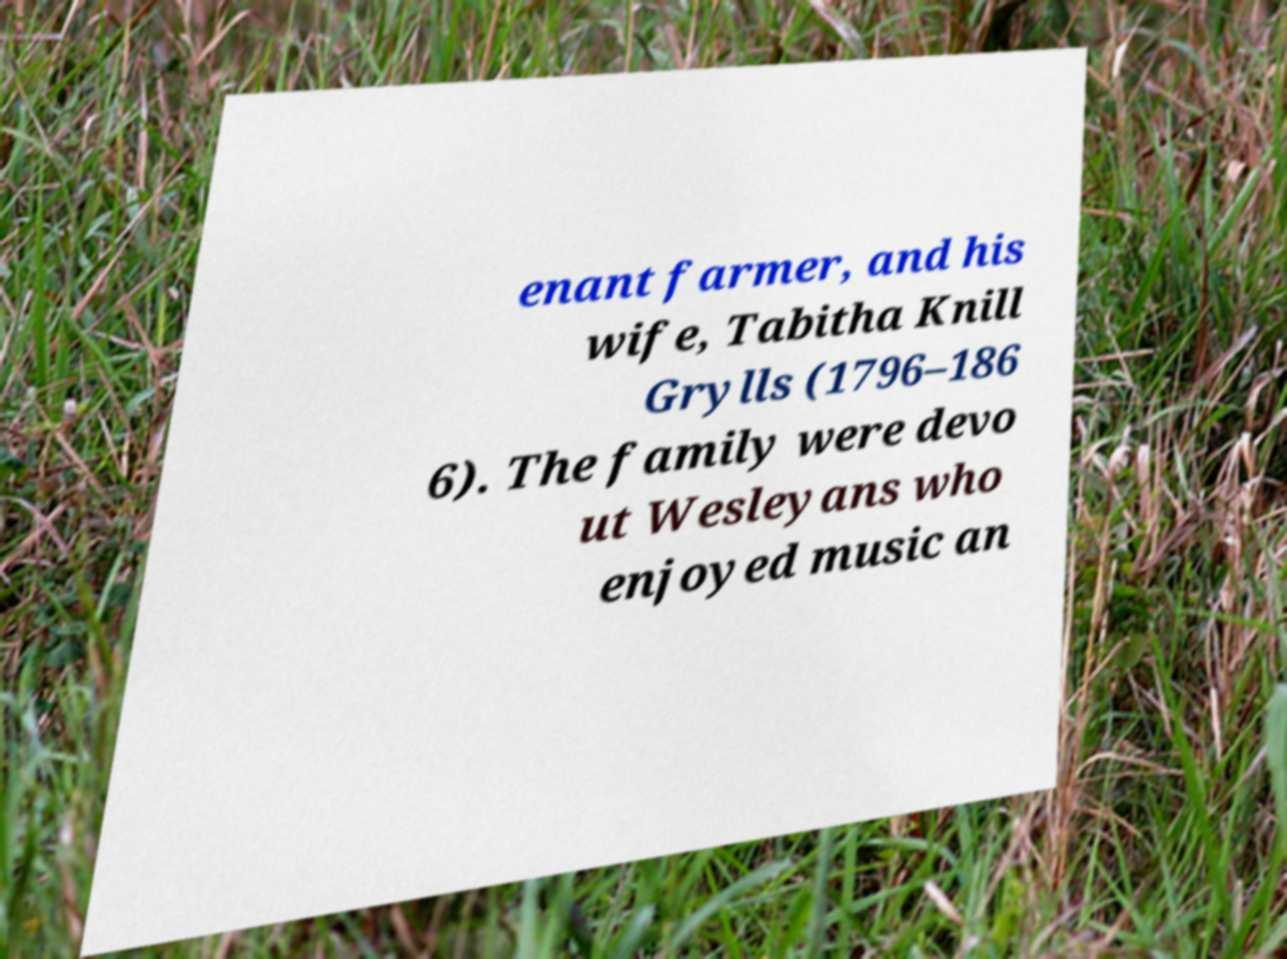What messages or text are displayed in this image? I need them in a readable, typed format. enant farmer, and his wife, Tabitha Knill Grylls (1796–186 6). The family were devo ut Wesleyans who enjoyed music an 